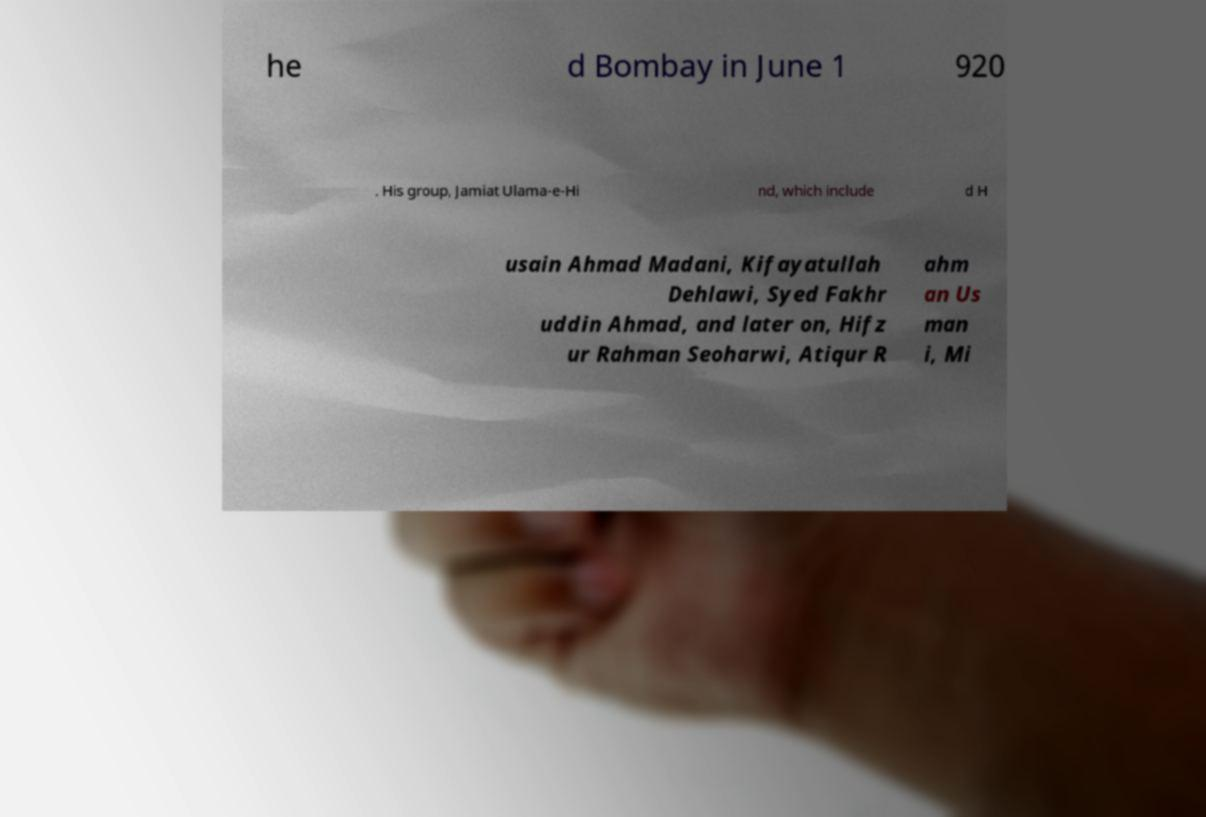There's text embedded in this image that I need extracted. Can you transcribe it verbatim? he d Bombay in June 1 920 . His group, Jamiat Ulama-e-Hi nd, which include d H usain Ahmad Madani, Kifayatullah Dehlawi, Syed Fakhr uddin Ahmad, and later on, Hifz ur Rahman Seoharwi, Atiqur R ahm an Us man i, Mi 